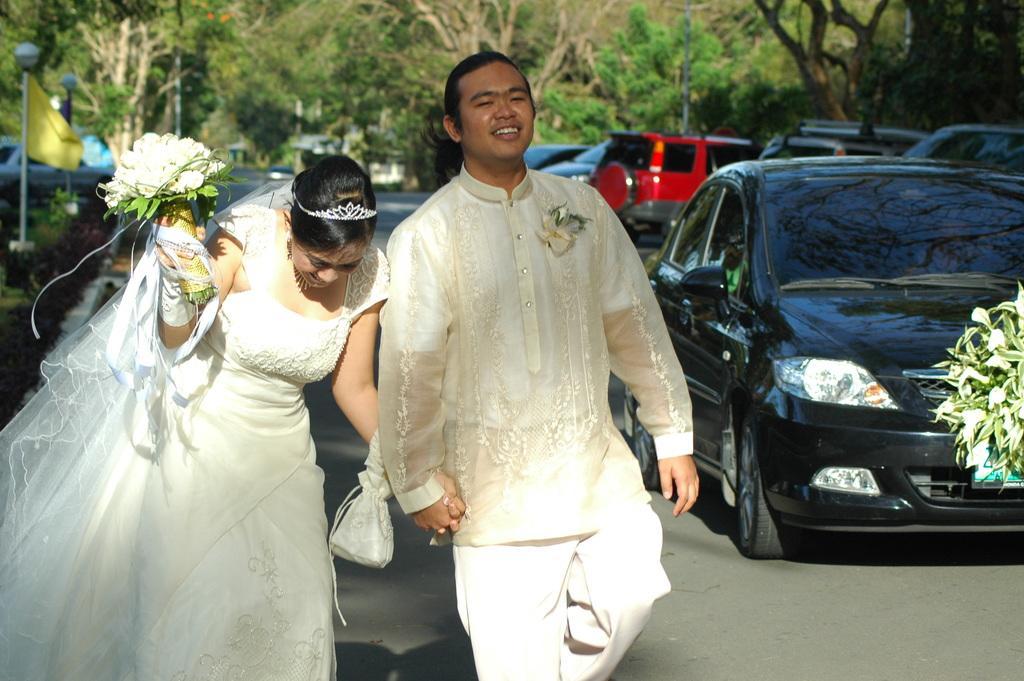Describe this image in one or two sentences. In the center of the image we can see man and woman on the road. On the right side of the image there is a car and flowers. In the background there are flags, poles, cars, road and trees. 